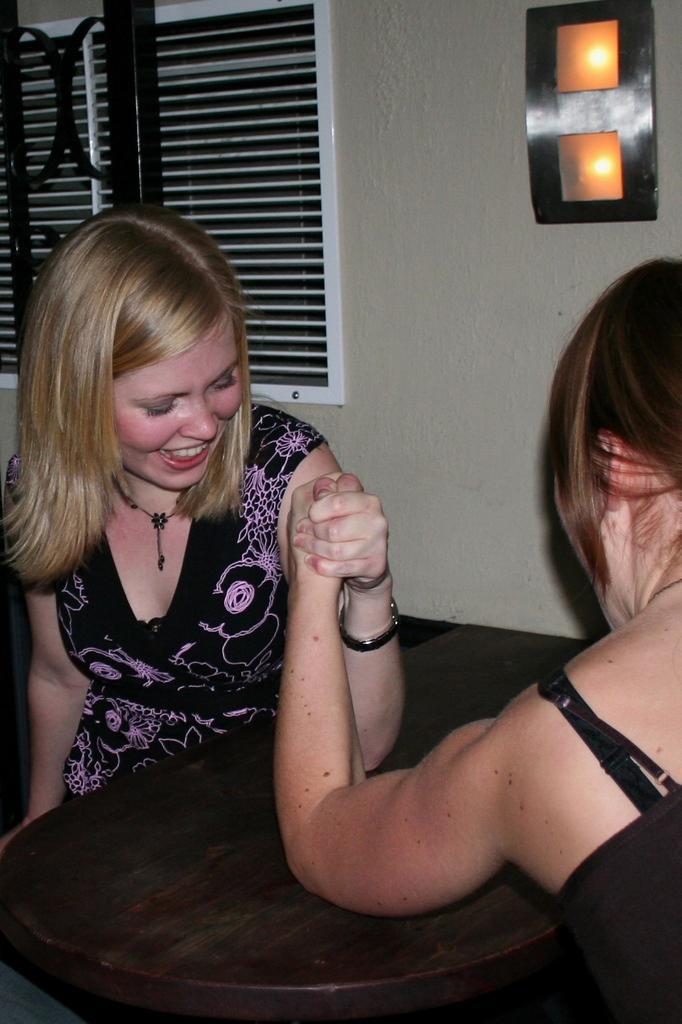How would you summarize this image in a sentence or two? In this picture we can see there are two people sitting and in front of the people there is a wooden table. Behind the people there is a wall with a window. 